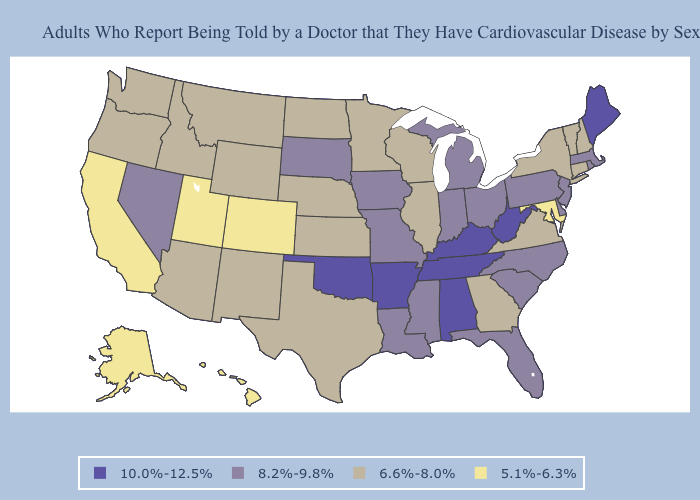Name the states that have a value in the range 10.0%-12.5%?
Write a very short answer. Alabama, Arkansas, Kentucky, Maine, Oklahoma, Tennessee, West Virginia. Among the states that border Maine , which have the highest value?
Write a very short answer. New Hampshire. Among the states that border Louisiana , does Texas have the lowest value?
Write a very short answer. Yes. Which states hav the highest value in the MidWest?
Keep it brief. Indiana, Iowa, Michigan, Missouri, Ohio, South Dakota. What is the highest value in the USA?
Keep it brief. 10.0%-12.5%. Name the states that have a value in the range 8.2%-9.8%?
Quick response, please. Delaware, Florida, Indiana, Iowa, Louisiana, Massachusetts, Michigan, Mississippi, Missouri, Nevada, New Jersey, North Carolina, Ohio, Pennsylvania, Rhode Island, South Carolina, South Dakota. Among the states that border Tennessee , does Alabama have the highest value?
Write a very short answer. Yes. Does Alaska have the highest value in the West?
Answer briefly. No. Does New Mexico have the same value as Alabama?
Quick response, please. No. Is the legend a continuous bar?
Be succinct. No. Name the states that have a value in the range 5.1%-6.3%?
Write a very short answer. Alaska, California, Colorado, Hawaii, Maryland, Utah. Does the map have missing data?
Quick response, please. No. What is the lowest value in states that border Ohio?
Give a very brief answer. 8.2%-9.8%. Does Missouri have a lower value than Arkansas?
Write a very short answer. Yes. Among the states that border Nebraska , does Missouri have the highest value?
Keep it brief. Yes. 